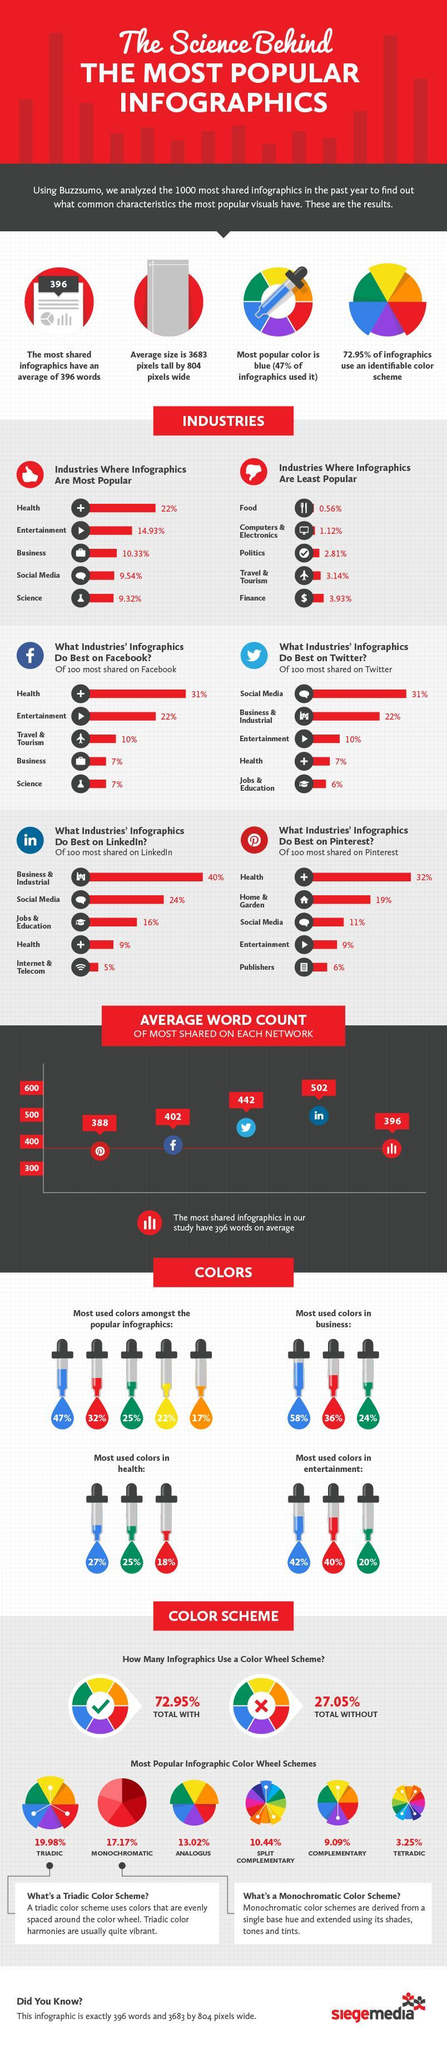What percentage of infographics based on business is shared on Facebook?
Answer the question with a short phrase. 7% What is the average word count of the most shared infographics on Twitter? 442 What percentage of infographics based on entertainment is shared on Twitter? 10% What percentage of the total infographics are used without a color wheel scheme? 27.05% Which industry based infographics is shared least on the Pinterest? Publishers What is the percentage of green color used in the infographics of health industry? 25% What percentage of the infographics use an analogus color wheel scheme? 13.02% Which is the second-most used infographic color by the business industry - Blue, Green, Red or Yellow? Red What percentage of the infographics is used by the travel & tourism industry? 3.14% Which industry based infographics is shared mostly on the Linkedin? Business & Industrial 